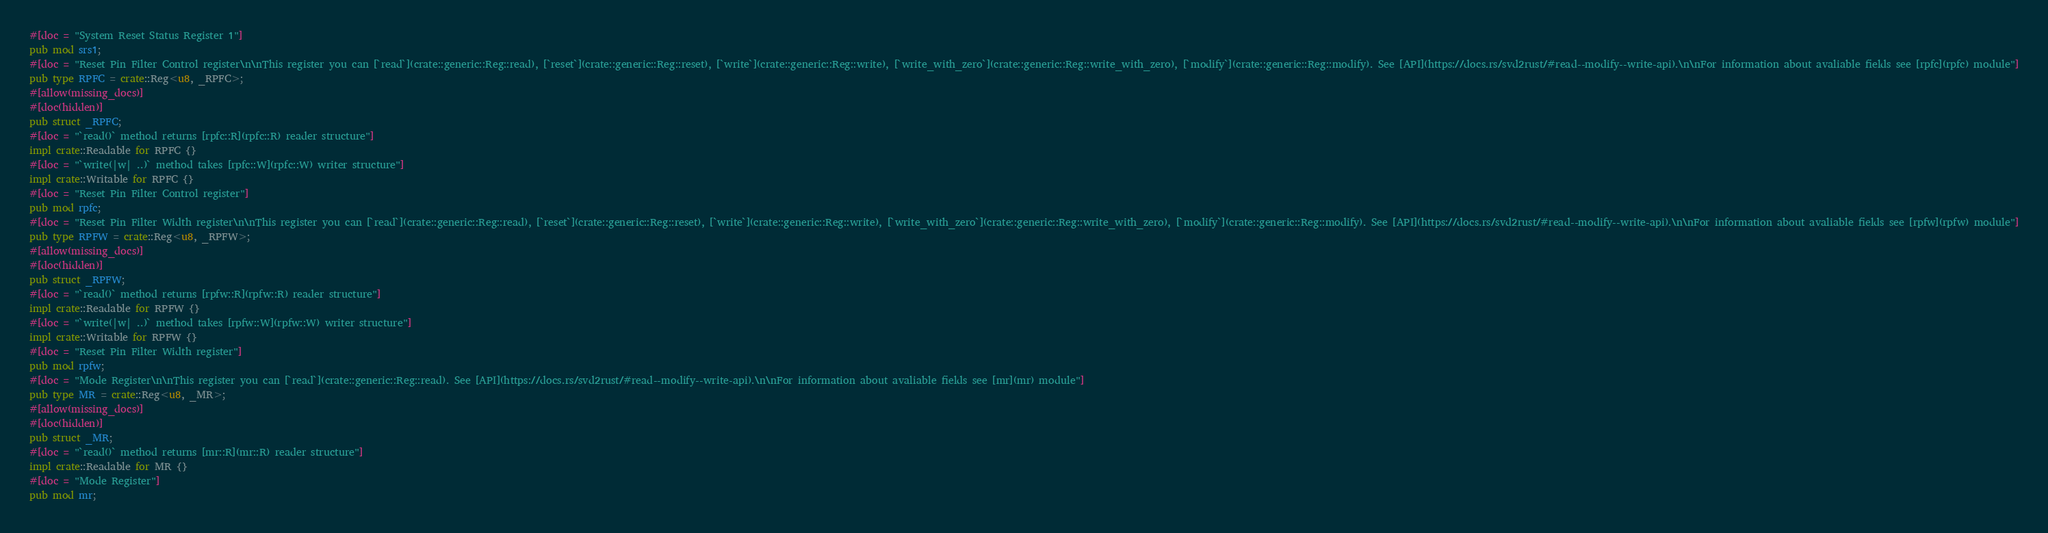Convert code to text. <code><loc_0><loc_0><loc_500><loc_500><_Rust_>#[doc = "System Reset Status Register 1"]
pub mod srs1;
#[doc = "Reset Pin Filter Control register\n\nThis register you can [`read`](crate::generic::Reg::read), [`reset`](crate::generic::Reg::reset), [`write`](crate::generic::Reg::write), [`write_with_zero`](crate::generic::Reg::write_with_zero), [`modify`](crate::generic::Reg::modify). See [API](https://docs.rs/svd2rust/#read--modify--write-api).\n\nFor information about avaliable fields see [rpfc](rpfc) module"]
pub type RPFC = crate::Reg<u8, _RPFC>;
#[allow(missing_docs)]
#[doc(hidden)]
pub struct _RPFC;
#[doc = "`read()` method returns [rpfc::R](rpfc::R) reader structure"]
impl crate::Readable for RPFC {}
#[doc = "`write(|w| ..)` method takes [rpfc::W](rpfc::W) writer structure"]
impl crate::Writable for RPFC {}
#[doc = "Reset Pin Filter Control register"]
pub mod rpfc;
#[doc = "Reset Pin Filter Width register\n\nThis register you can [`read`](crate::generic::Reg::read), [`reset`](crate::generic::Reg::reset), [`write`](crate::generic::Reg::write), [`write_with_zero`](crate::generic::Reg::write_with_zero), [`modify`](crate::generic::Reg::modify). See [API](https://docs.rs/svd2rust/#read--modify--write-api).\n\nFor information about avaliable fields see [rpfw](rpfw) module"]
pub type RPFW = crate::Reg<u8, _RPFW>;
#[allow(missing_docs)]
#[doc(hidden)]
pub struct _RPFW;
#[doc = "`read()` method returns [rpfw::R](rpfw::R) reader structure"]
impl crate::Readable for RPFW {}
#[doc = "`write(|w| ..)` method takes [rpfw::W](rpfw::W) writer structure"]
impl crate::Writable for RPFW {}
#[doc = "Reset Pin Filter Width register"]
pub mod rpfw;
#[doc = "Mode Register\n\nThis register you can [`read`](crate::generic::Reg::read). See [API](https://docs.rs/svd2rust/#read--modify--write-api).\n\nFor information about avaliable fields see [mr](mr) module"]
pub type MR = crate::Reg<u8, _MR>;
#[allow(missing_docs)]
#[doc(hidden)]
pub struct _MR;
#[doc = "`read()` method returns [mr::R](mr::R) reader structure"]
impl crate::Readable for MR {}
#[doc = "Mode Register"]
pub mod mr;
</code> 